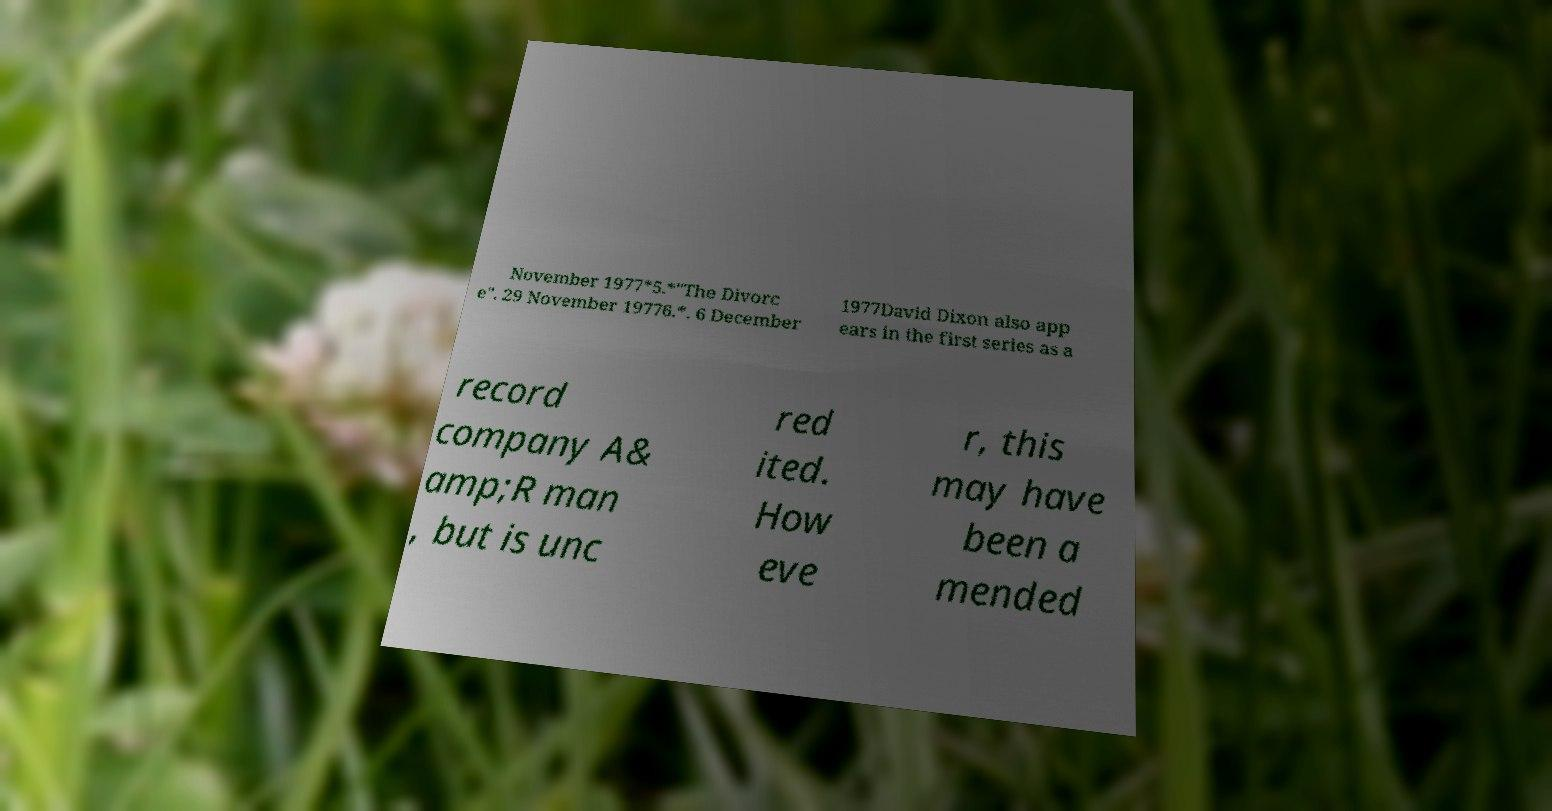For documentation purposes, I need the text within this image transcribed. Could you provide that? November 1977*5.*"The Divorc e". 29 November 19776.*. 6 December 1977David Dixon also app ears in the first series as a record company A& amp;R man , but is unc red ited. How eve r, this may have been a mended 